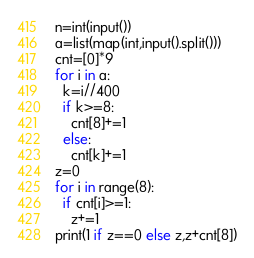<code> <loc_0><loc_0><loc_500><loc_500><_Python_>n=int(input())
a=list(map(int,input().split()))
cnt=[0]*9
for i in a:
  k=i//400
  if k>=8:
    cnt[8]+=1
  else:
    cnt[k]+=1
z=0
for i in range(8):
  if cnt[i]>=1:
    z+=1
print(1 if z==0 else z,z+cnt[8])</code> 